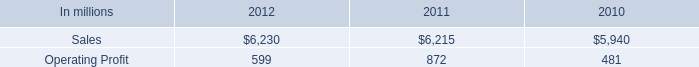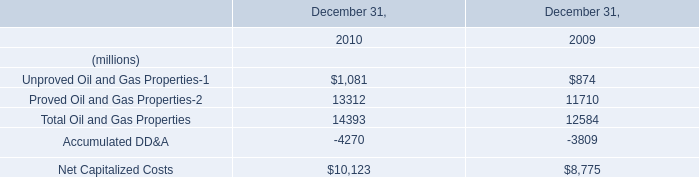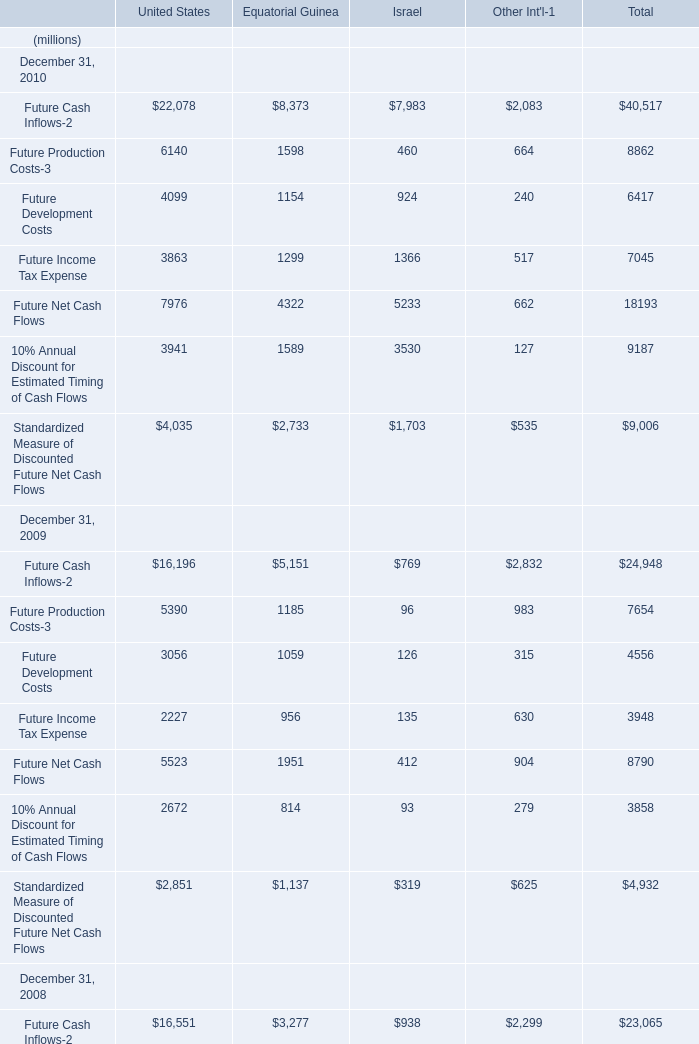What was the average of the proved Oil and Gas Properties-2 in the years where UnProved Oil and Gas Properties-1 is positive? (in million) 
Computations: ((13312 + 11710) / 2)
Answer: 12511.0. 